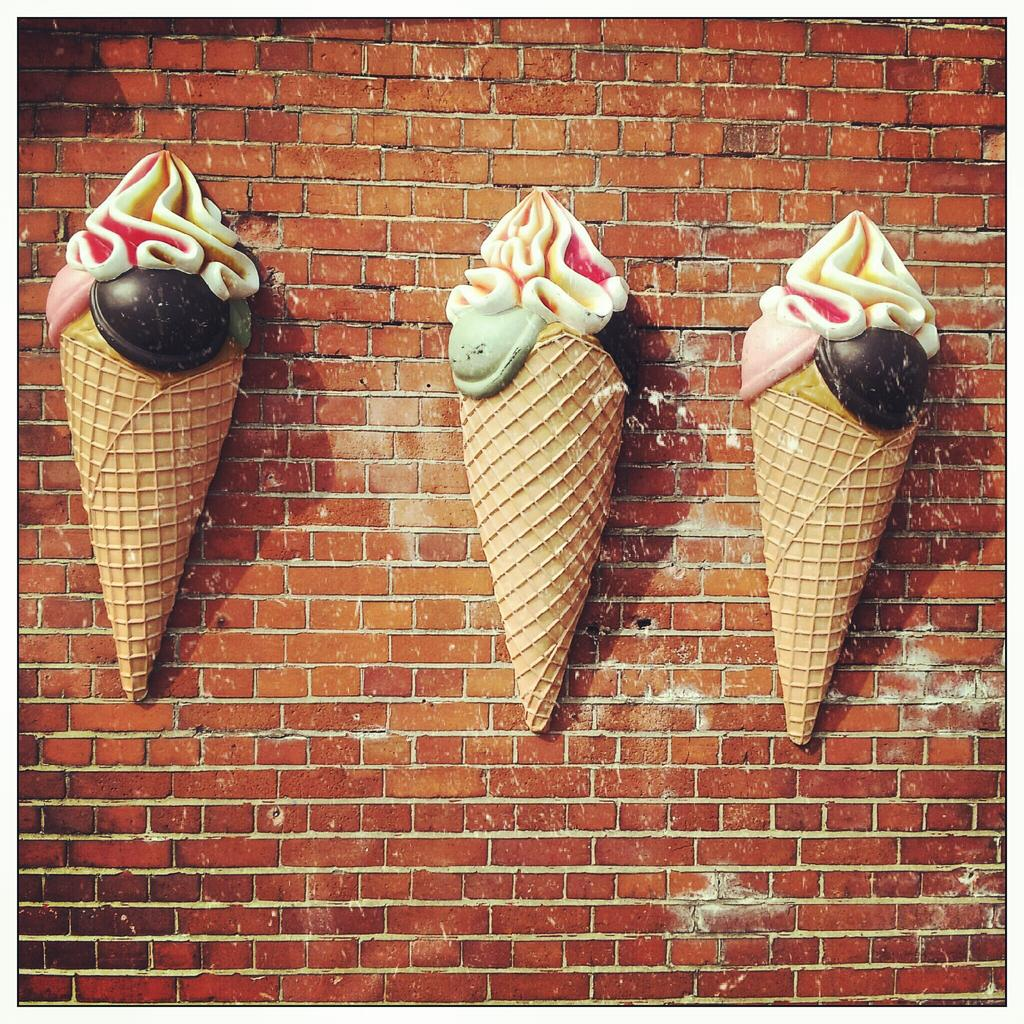What is depicted on the wall in the image? There are ice creams on the wall in the image. What type of fold can be seen in the image? There is no fold present in the image; it features ice creams on the wall. What kind of pleasure can be experienced by the ice creams in the image? The ice creams in the image are not capable of experiencing pleasure, as they are inanimate objects. 